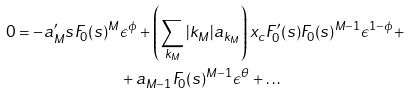<formula> <loc_0><loc_0><loc_500><loc_500>0 = - a _ { M } ^ { \prime } s F _ { 0 } ( s ) ^ { M } & \epsilon ^ { \phi } + \left ( \sum _ { { k } _ { M } } | { k } _ { M } | a _ { { k } _ { M } } \right ) x _ { c } F _ { 0 } ^ { \prime } ( s ) F _ { 0 } ( s ) ^ { M - 1 } \epsilon ^ { 1 - \phi } + \\ & + a _ { M - 1 } F _ { 0 } ( s ) ^ { M - 1 } \epsilon ^ { \theta } + \dots</formula> 